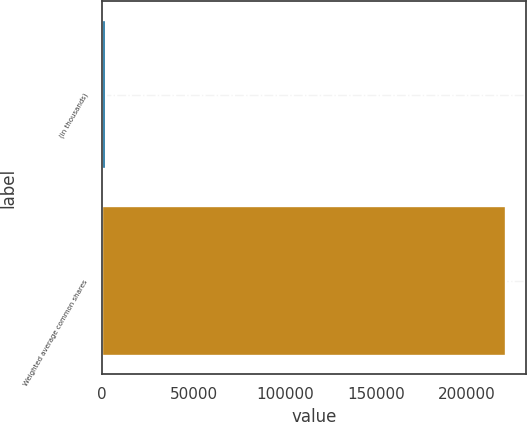Convert chart to OTSL. <chart><loc_0><loc_0><loc_500><loc_500><bar_chart><fcel>(in thousands)<fcel>Weighted average common shares<nl><fcel>2009<fcel>221082<nl></chart> 